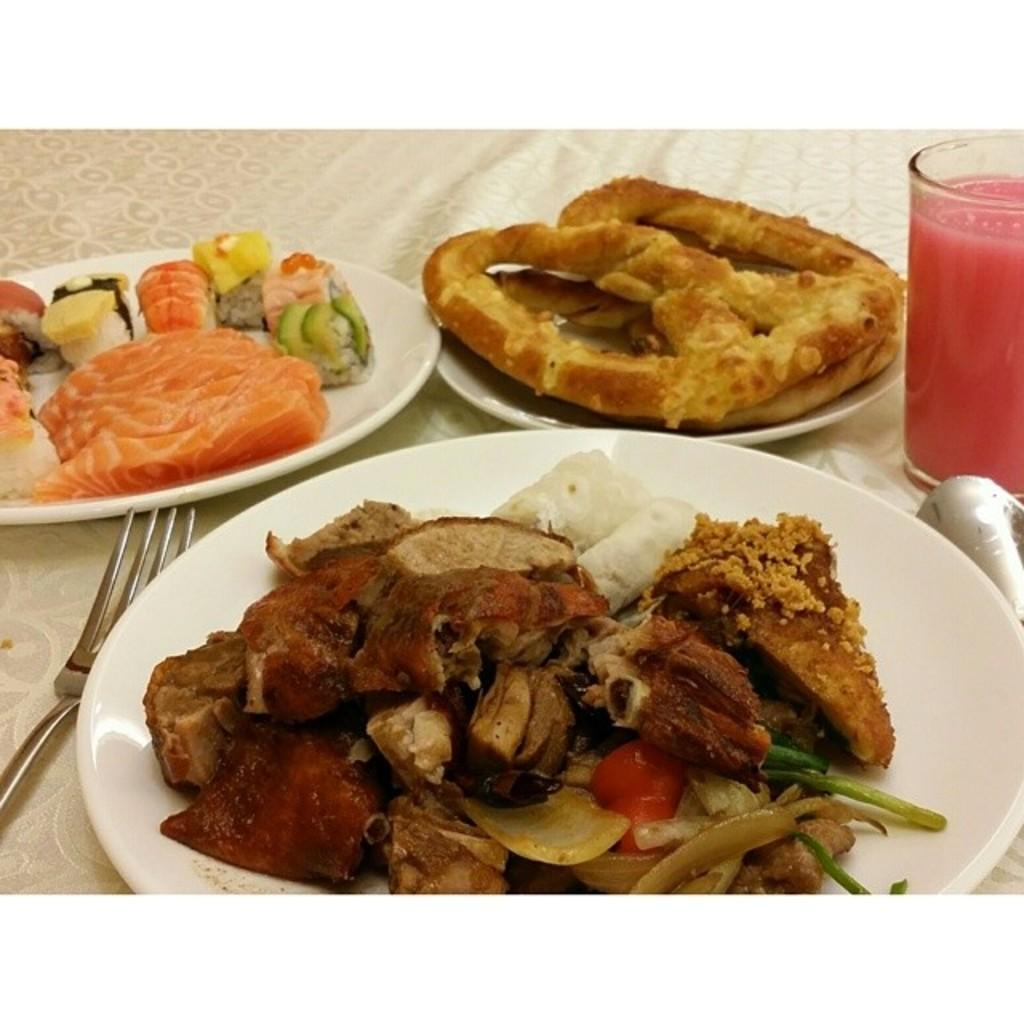How many plates can be seen in the image? There are three plates in the image. What utensils are visible in the image? There is a fork and a spoon in the image. What is contained in the glass in the image? There is a glass of drink in the image. What is on top of the plates in the image? There is food present on the plates. What is located at the bottom of the image? There is a cloth at the bottom of the image. Can you see a mountain in the background of the image? There is no mountain visible in the image. Is there a tiger present on any of the plates in the image? There are no animals, including tigers, present on the plates in the image. 